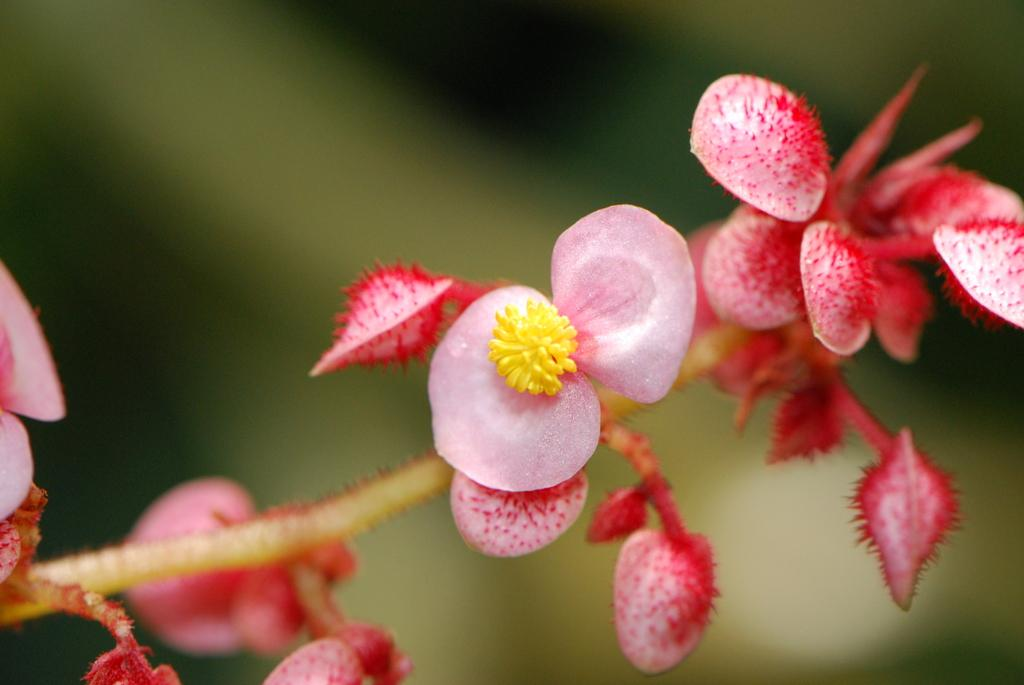What type of living organisms can be seen in the image? There are flowers in the image. Can you describe the background of the image? The background of the image is blurry. What type of sport is being played in the image? There is no sport being played in the image; it features flowers and a blurry background. What type of knowledge is being displayed in the image? There is no specific knowledge being displayed in the image; it features flowers and a blurry background. 